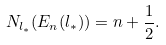<formula> <loc_0><loc_0><loc_500><loc_500>N _ { l _ { * } } ( E _ { n } ( l _ { * } ) ) = n + \frac { 1 } { 2 } .</formula> 